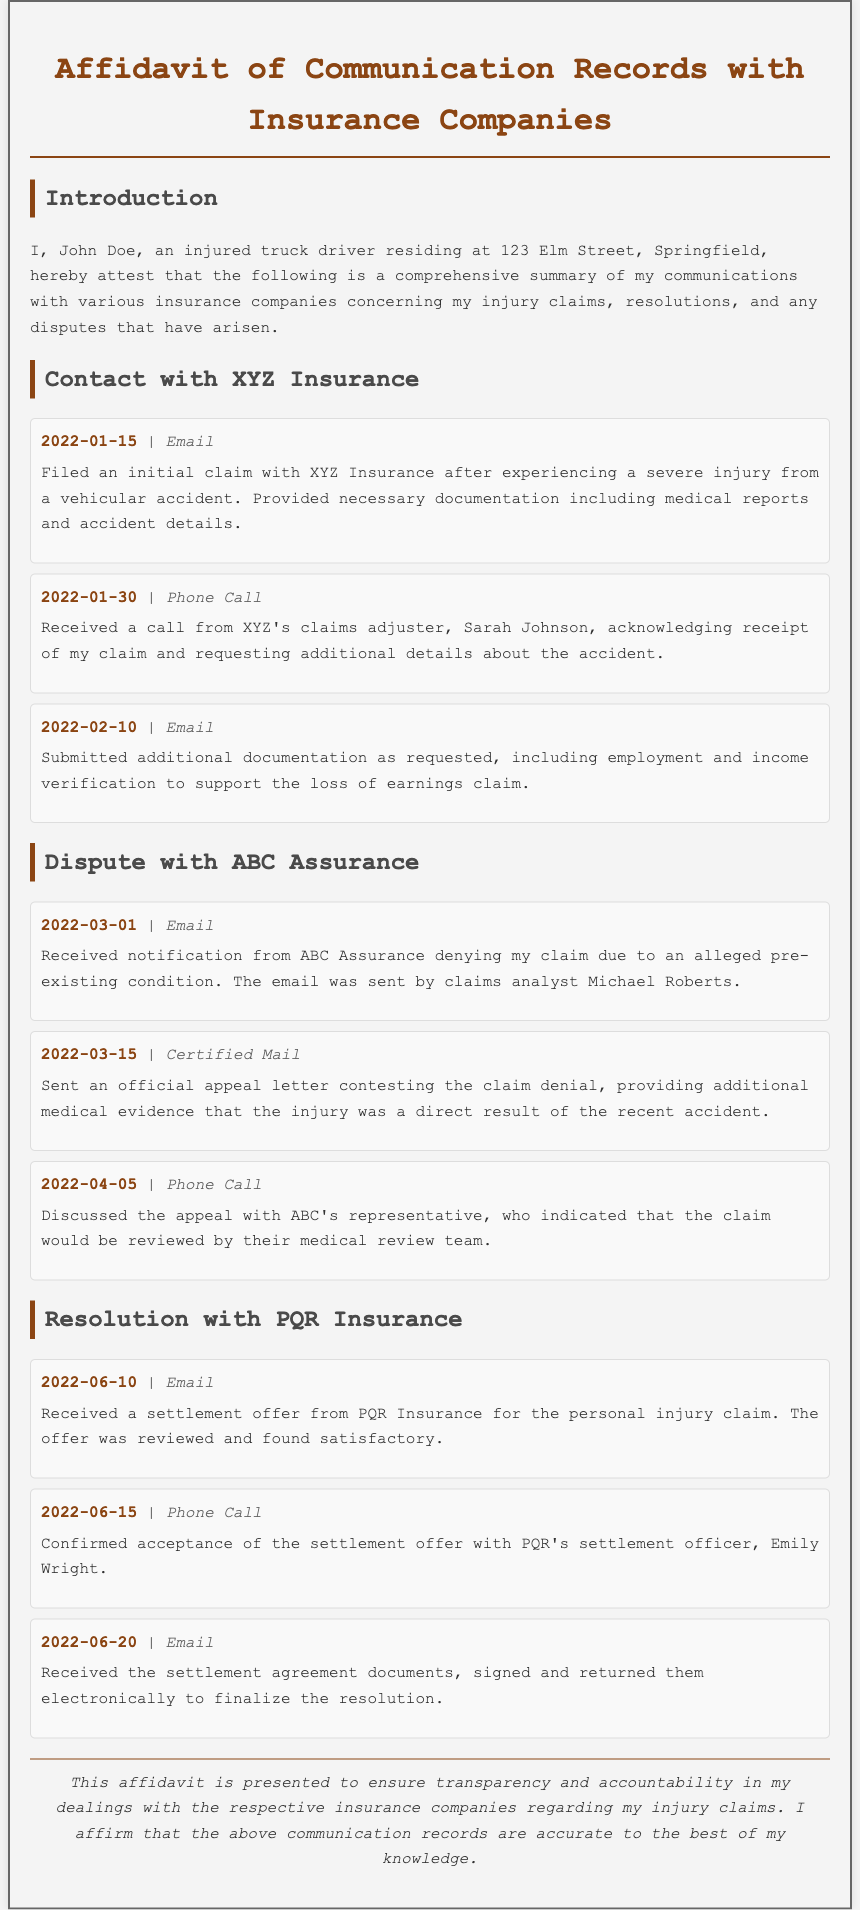What is the name of the insurance company involved in the initial claim? The document states that the injured truck driver filed an initial claim with XYZ Insurance following their injury.
Answer: XYZ Insurance Who is the claims adjuster from XYZ Insurance? The document indicates that the claims adjuster who contacted the injured truck driver is Sarah Johnson.
Answer: Sarah Johnson What was the date of the claim denial from ABC Assurance? The document notes that the claim denial notification from ABC Assurance was received on March 1, 2022.
Answer: 2022-03-01 What additional evidence was provided in the appeal letter to ABC Assurance? The affidavit mentions that additional medical evidence was provided to contest the claim denial, showing that the injury was a direct result of the accident.
Answer: Additional medical evidence What was the settlement offer date from PQR Insurance? According to the document, the settlement offer from PQR Insurance was received on June 10, 2022.
Answer: 2022-06-10 Who is the settlement officer from PQR Insurance? The document states that the settlement officer who confirmed the settlement acceptance is Emily Wright.
Answer: Emily Wright How did the injured truck driver submit the additional documentation to XYZ Insurance? The document indicates that the additional documentation was submitted via email.
Answer: Email What type of communication was used for the official appeal to ABC Assurance? The document records that the official appeal letter was sent via certified mail.
Answer: Certified Mail What is the primary purpose of this affidavit? The document states that the affidavit is presented to ensure transparency and accountability in dealings with insurance companies regarding the injury claims.
Answer: Transparency and accountability 